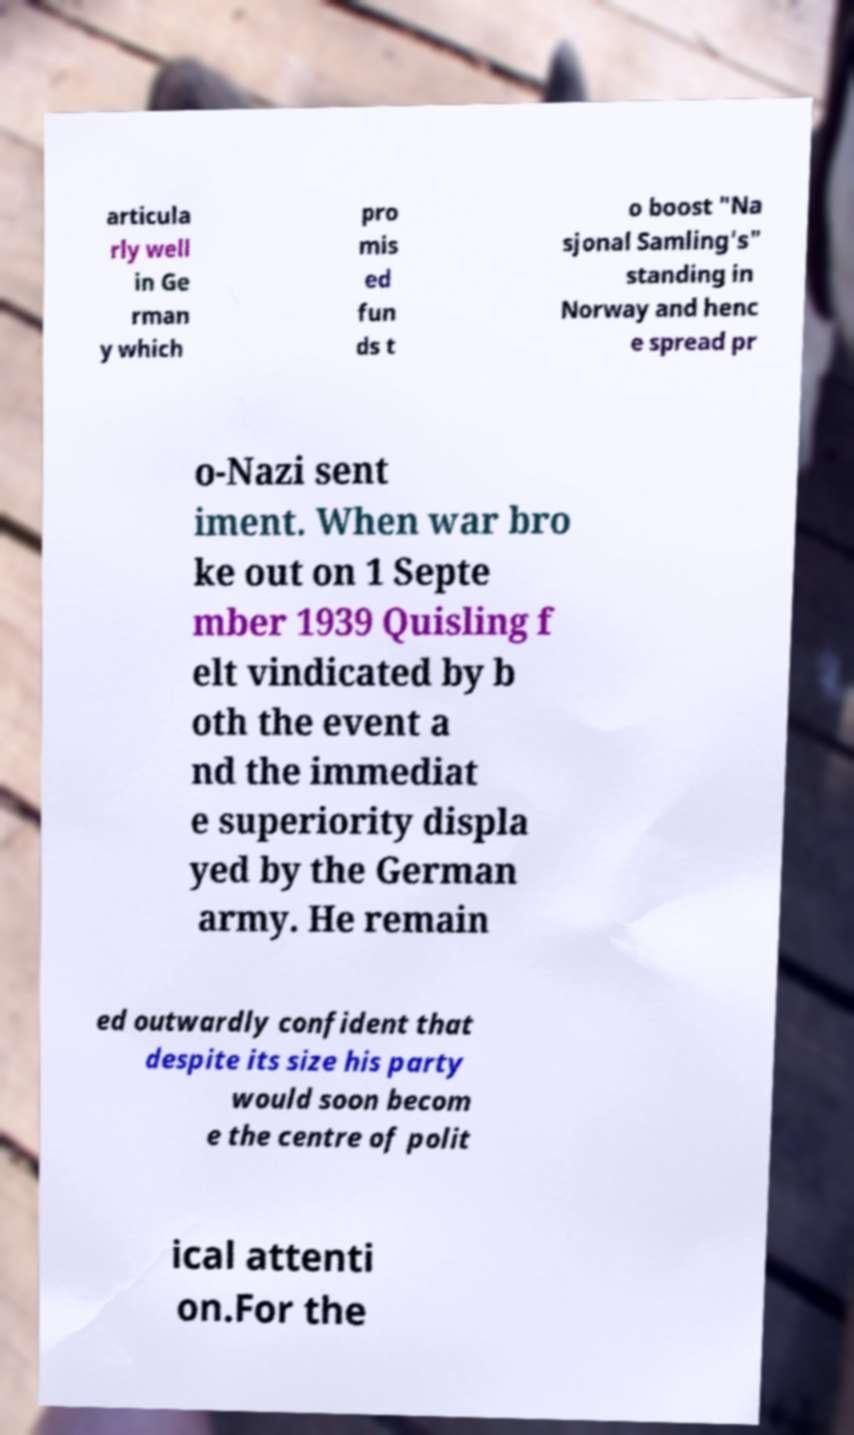What messages or text are displayed in this image? I need them in a readable, typed format. articula rly well in Ge rman y which pro mis ed fun ds t o boost "Na sjonal Samling's" standing in Norway and henc e spread pr o-Nazi sent iment. When war bro ke out on 1 Septe mber 1939 Quisling f elt vindicated by b oth the event a nd the immediat e superiority displa yed by the German army. He remain ed outwardly confident that despite its size his party would soon becom e the centre of polit ical attenti on.For the 